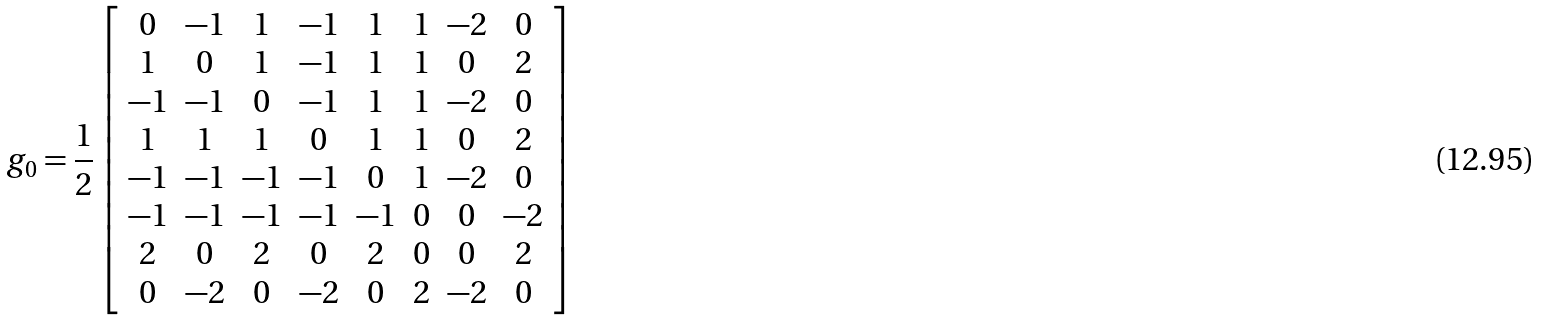<formula> <loc_0><loc_0><loc_500><loc_500>g _ { 0 } = \frac { 1 } { 2 } \left [ \begin{array} { c c c c c c c c } 0 & - 1 & 1 & - 1 & 1 & 1 & - 2 & 0 \\ 1 & 0 & 1 & - 1 & 1 & 1 & 0 & 2 \\ - 1 & - 1 & 0 & - 1 & 1 & 1 & - 2 & 0 \\ 1 & 1 & 1 & 0 & 1 & 1 & 0 & 2 \\ - 1 & - 1 & - 1 & - 1 & 0 & 1 & - 2 & 0 \\ - 1 & - 1 & - 1 & - 1 & - 1 & 0 & 0 & - 2 \\ 2 & 0 & 2 & 0 & 2 & 0 & 0 & 2 \\ 0 & - 2 & 0 & - 2 & 0 & 2 & - 2 & 0 \end{array} \right ]</formula> 